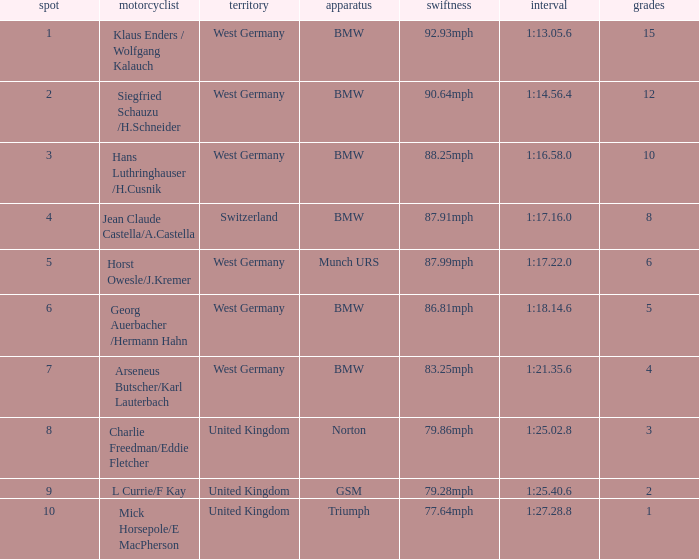Which places have points larger than 10? None. 